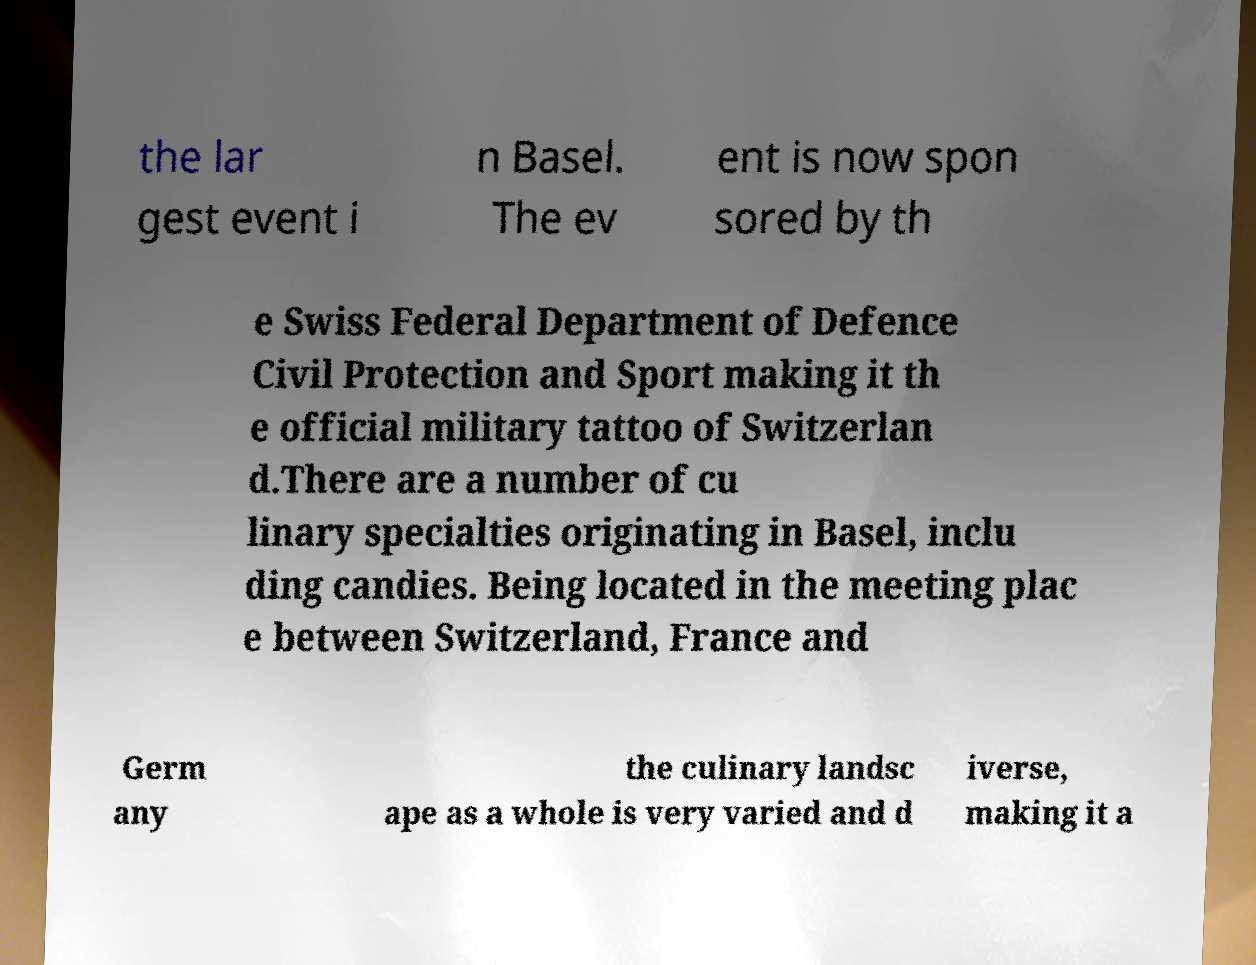Please identify and transcribe the text found in this image. the lar gest event i n Basel. The ev ent is now spon sored by th e Swiss Federal Department of Defence Civil Protection and Sport making it th e official military tattoo of Switzerlan d.There are a number of cu linary specialties originating in Basel, inclu ding candies. Being located in the meeting plac e between Switzerland, France and Germ any the culinary landsc ape as a whole is very varied and d iverse, making it a 